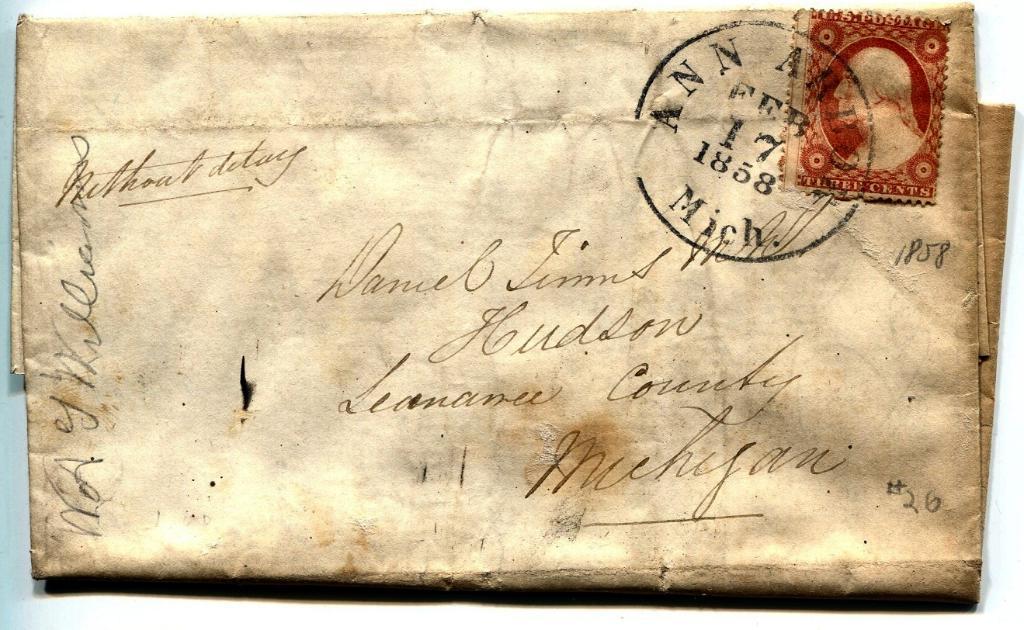How old is this mail?
Your answer should be very brief. 1858. What state is the post mark?
Provide a succinct answer. Michigan. 